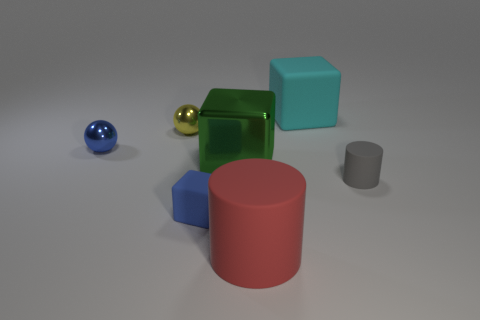What is the shape of the tiny metal thing that is the same color as the small cube?
Your response must be concise. Sphere. What size is the cylinder behind the red cylinder?
Ensure brevity in your answer.  Small. What shape is the yellow object that is the same size as the blue metal sphere?
Make the answer very short. Sphere. Are the big cyan block behind the blue sphere and the cylinder that is on the right side of the big cylinder made of the same material?
Your answer should be compact. Yes. There is a thing on the right side of the block that is behind the blue metallic thing; what is it made of?
Provide a short and direct response. Rubber. What is the size of the blue metal thing that is left of the object to the right of the large matte thing behind the small gray matte object?
Keep it short and to the point. Small. Does the green shiny block have the same size as the blue sphere?
Provide a succinct answer. No. Is the shape of the large thing behind the big green cube the same as the big rubber object in front of the large cyan rubber object?
Your response must be concise. No. Is there a blue shiny ball that is in front of the small rubber object that is left of the cyan matte object?
Offer a terse response. No. Are any gray matte cylinders visible?
Ensure brevity in your answer.  Yes. 